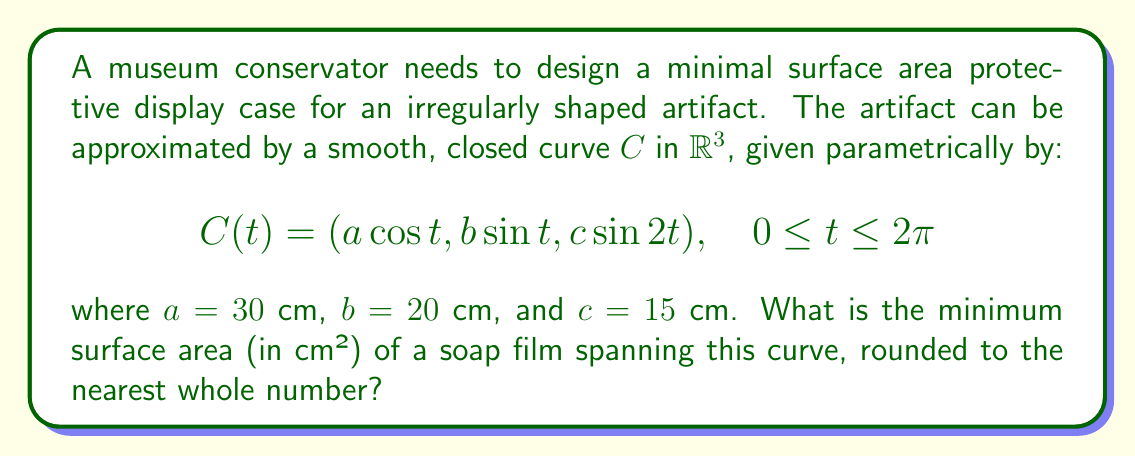Could you help me with this problem? To solve this problem, we'll follow these steps:

1) The minimal surface area spanning a closed curve is given by a soap film solution. This surface minimizes the area and is described by minimal surface equations.

2) For a parametric curve $C(t) = (x(t), y(t), z(t))$, the area of the minimal surface is given by the formula:

   $$A = \frac{1}{2} \left|\int_C (x dy - y dx)\right|$$

3) In our case:
   $x = a \cos t$
   $y = b \sin t$
   $z = c \sin 2t$

4) We need to calculate $dx$ and $dy$:
   $dx = -a \sin t \, dt$
   $dy = b \cos t \, dt$

5) Substituting into the area formula:

   $$A = \frac{1}{2} \left|\int_0^{2\pi} (a \cos t \cdot b \cos t + b \sin t \cdot a \sin t) \, dt\right|$$

6) Simplifying:

   $$A = \frac{1}{2} \left|ab \int_0^{2\pi} (\cos^2 t + \sin^2 t) \, dt\right|$$

7) We know that $\cos^2 t + \sin^2 t = 1$ for all $t$, so:

   $$A = \frac{1}{2} \left|ab \int_0^{2\pi} 1 \, dt\right| = \frac{1}{2} |ab \cdot 2\pi| = \pi ab$$

8) Substituting the values:

   $$A = \pi \cdot 30 \text{ cm} \cdot 20 \text{ cm} = 1885.0 \text{ cm}^2$$

9) Rounding to the nearest whole number:

   $$A \approx 1885 \text{ cm}^2$$
Answer: 1885 cm² 